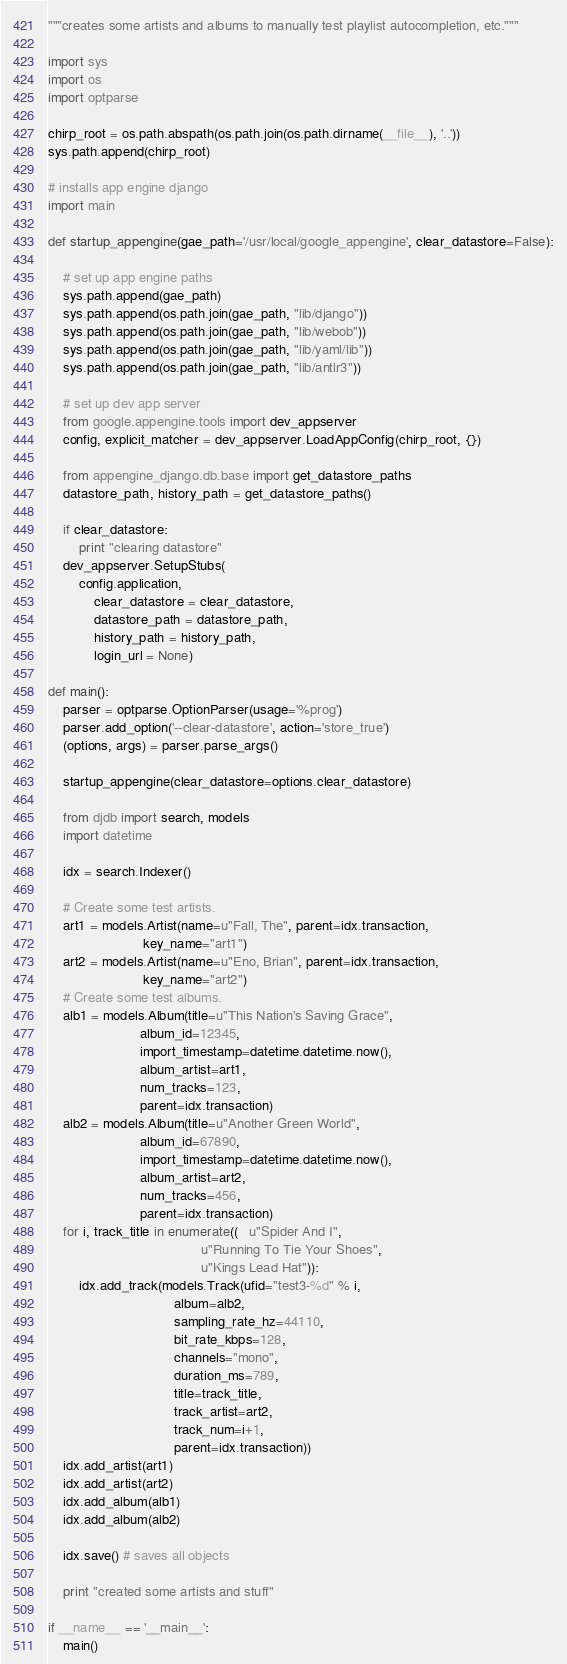<code> <loc_0><loc_0><loc_500><loc_500><_Python_>
"""creates some artists and albums to manually test playlist autocompletion, etc."""

import sys
import os
import optparse

chirp_root = os.path.abspath(os.path.join(os.path.dirname(__file__), '..'))
sys.path.append(chirp_root)

# installs app engine django
import main

def startup_appengine(gae_path='/usr/local/google_appengine', clear_datastore=False):
    
    # set up app engine paths
    sys.path.append(gae_path)
    sys.path.append(os.path.join(gae_path, "lib/django"))
    sys.path.append(os.path.join(gae_path, "lib/webob"))
    sys.path.append(os.path.join(gae_path, "lib/yaml/lib"))
    sys.path.append(os.path.join(gae_path, "lib/antlr3"))
    
    # set up dev app server
    from google.appengine.tools import dev_appserver
    config, explicit_matcher = dev_appserver.LoadAppConfig(chirp_root, {})
    
    from appengine_django.db.base import get_datastore_paths
    datastore_path, history_path = get_datastore_paths()
    
    if clear_datastore:
        print "clearing datastore"
    dev_appserver.SetupStubs(
        config.application, 
            clear_datastore = clear_datastore,
            datastore_path = datastore_path, 
            history_path = history_path, 
            login_url = None)

def main():
    parser = optparse.OptionParser(usage='%prog')
    parser.add_option('--clear-datastore', action='store_true')
    (options, args) = parser.parse_args()
    
    startup_appengine(clear_datastore=options.clear_datastore)
    
    from djdb import search, models
    import datetime

    idx = search.Indexer()
    
    # Create some test artists.
    art1 = models.Artist(name=u"Fall, The", parent=idx.transaction,
                         key_name="art1")
    art2 = models.Artist(name=u"Eno, Brian", parent=idx.transaction,
                         key_name="art2")
    # Create some test albums.
    alb1 = models.Album(title=u"This Nation's Saving Grace",
                        album_id=12345,
                        import_timestamp=datetime.datetime.now(),
                        album_artist=art1,
                        num_tracks=123,
                        parent=idx.transaction)
    alb2 = models.Album(title=u"Another Green World",
                        album_id=67890,
                        import_timestamp=datetime.datetime.now(),
                        album_artist=art2,
                        num_tracks=456,
                        parent=idx.transaction)
    for i, track_title in enumerate((   u"Spider And I", 
                                        u"Running To Tie Your Shoes", 
                                        u"Kings Lead Hat")):
        idx.add_track(models.Track(ufid="test3-%d" % i,
                                 album=alb2,
                                 sampling_rate_hz=44110,
                                 bit_rate_kbps=128,
                                 channels="mono",
                                 duration_ms=789,
                                 title=track_title,
                                 track_artist=art2,
                                 track_num=i+1,
                                 parent=idx.transaction))
    idx.add_artist(art1)
    idx.add_artist(art2)
    idx.add_album(alb1)
    idx.add_album(alb2)
    
    idx.save() # saves all objects
    
    print "created some artists and stuff"

if __name__ == '__main__':
    main()</code> 